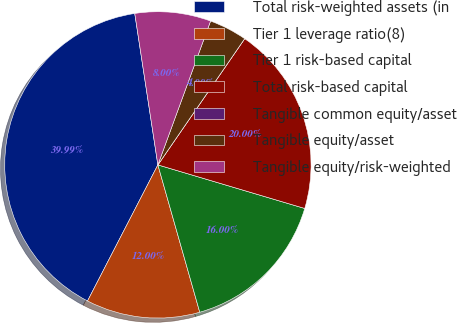Convert chart. <chart><loc_0><loc_0><loc_500><loc_500><pie_chart><fcel>Total risk-weighted assets (in<fcel>Tier 1 leverage ratio(8)<fcel>Tier 1 risk-based capital<fcel>Total risk-based capital<fcel>Tangible common equity/asset<fcel>Tangible equity/asset<fcel>Tangible equity/risk-weighted<nl><fcel>39.99%<fcel>12.0%<fcel>16.0%<fcel>20.0%<fcel>0.0%<fcel>4.0%<fcel>8.0%<nl></chart> 